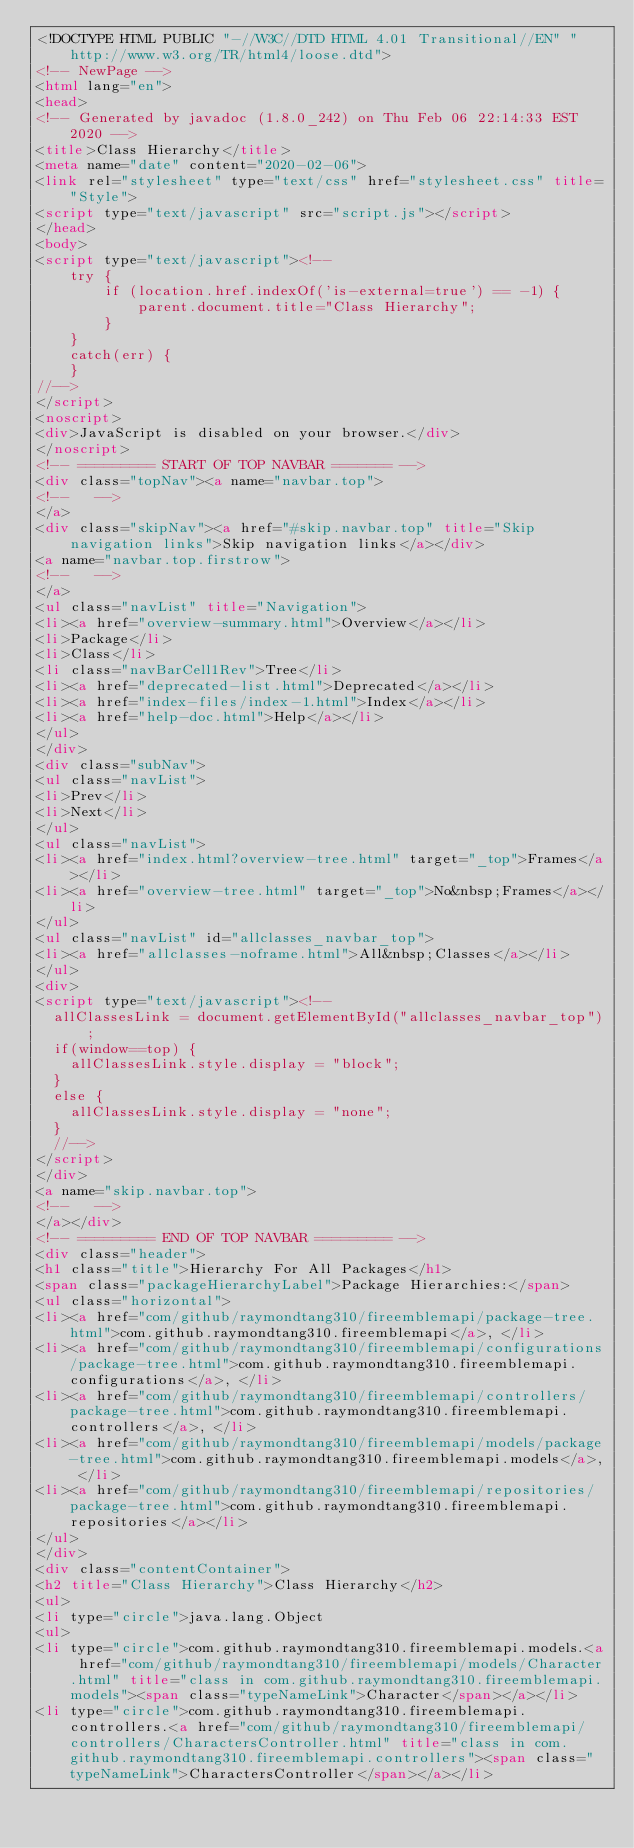Convert code to text. <code><loc_0><loc_0><loc_500><loc_500><_HTML_><!DOCTYPE HTML PUBLIC "-//W3C//DTD HTML 4.01 Transitional//EN" "http://www.w3.org/TR/html4/loose.dtd">
<!-- NewPage -->
<html lang="en">
<head>
<!-- Generated by javadoc (1.8.0_242) on Thu Feb 06 22:14:33 EST 2020 -->
<title>Class Hierarchy</title>
<meta name="date" content="2020-02-06">
<link rel="stylesheet" type="text/css" href="stylesheet.css" title="Style">
<script type="text/javascript" src="script.js"></script>
</head>
<body>
<script type="text/javascript"><!--
    try {
        if (location.href.indexOf('is-external=true') == -1) {
            parent.document.title="Class Hierarchy";
        }
    }
    catch(err) {
    }
//-->
</script>
<noscript>
<div>JavaScript is disabled on your browser.</div>
</noscript>
<!-- ========= START OF TOP NAVBAR ======= -->
<div class="topNav"><a name="navbar.top">
<!--   -->
</a>
<div class="skipNav"><a href="#skip.navbar.top" title="Skip navigation links">Skip navigation links</a></div>
<a name="navbar.top.firstrow">
<!--   -->
</a>
<ul class="navList" title="Navigation">
<li><a href="overview-summary.html">Overview</a></li>
<li>Package</li>
<li>Class</li>
<li class="navBarCell1Rev">Tree</li>
<li><a href="deprecated-list.html">Deprecated</a></li>
<li><a href="index-files/index-1.html">Index</a></li>
<li><a href="help-doc.html">Help</a></li>
</ul>
</div>
<div class="subNav">
<ul class="navList">
<li>Prev</li>
<li>Next</li>
</ul>
<ul class="navList">
<li><a href="index.html?overview-tree.html" target="_top">Frames</a></li>
<li><a href="overview-tree.html" target="_top">No&nbsp;Frames</a></li>
</ul>
<ul class="navList" id="allclasses_navbar_top">
<li><a href="allclasses-noframe.html">All&nbsp;Classes</a></li>
</ul>
<div>
<script type="text/javascript"><!--
  allClassesLink = document.getElementById("allclasses_navbar_top");
  if(window==top) {
    allClassesLink.style.display = "block";
  }
  else {
    allClassesLink.style.display = "none";
  }
  //-->
</script>
</div>
<a name="skip.navbar.top">
<!--   -->
</a></div>
<!-- ========= END OF TOP NAVBAR ========= -->
<div class="header">
<h1 class="title">Hierarchy For All Packages</h1>
<span class="packageHierarchyLabel">Package Hierarchies:</span>
<ul class="horizontal">
<li><a href="com/github/raymondtang310/fireemblemapi/package-tree.html">com.github.raymondtang310.fireemblemapi</a>, </li>
<li><a href="com/github/raymondtang310/fireemblemapi/configurations/package-tree.html">com.github.raymondtang310.fireemblemapi.configurations</a>, </li>
<li><a href="com/github/raymondtang310/fireemblemapi/controllers/package-tree.html">com.github.raymondtang310.fireemblemapi.controllers</a>, </li>
<li><a href="com/github/raymondtang310/fireemblemapi/models/package-tree.html">com.github.raymondtang310.fireemblemapi.models</a>, </li>
<li><a href="com/github/raymondtang310/fireemblemapi/repositories/package-tree.html">com.github.raymondtang310.fireemblemapi.repositories</a></li>
</ul>
</div>
<div class="contentContainer">
<h2 title="Class Hierarchy">Class Hierarchy</h2>
<ul>
<li type="circle">java.lang.Object
<ul>
<li type="circle">com.github.raymondtang310.fireemblemapi.models.<a href="com/github/raymondtang310/fireemblemapi/models/Character.html" title="class in com.github.raymondtang310.fireemblemapi.models"><span class="typeNameLink">Character</span></a></li>
<li type="circle">com.github.raymondtang310.fireemblemapi.controllers.<a href="com/github/raymondtang310/fireemblemapi/controllers/CharactersController.html" title="class in com.github.raymondtang310.fireemblemapi.controllers"><span class="typeNameLink">CharactersController</span></a></li></code> 